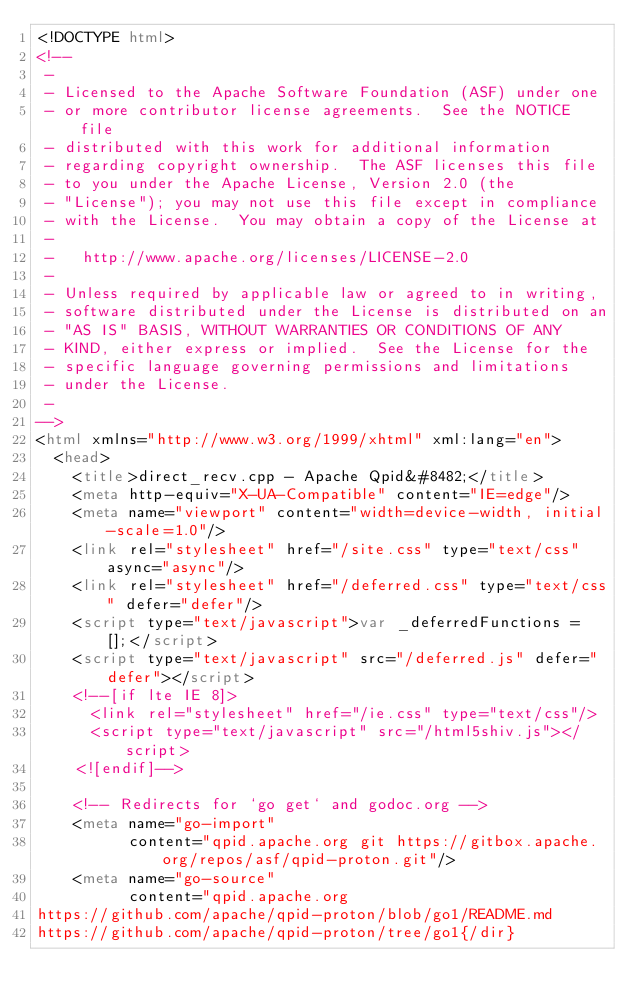Convert code to text. <code><loc_0><loc_0><loc_500><loc_500><_HTML_><!DOCTYPE html>
<!--
 -
 - Licensed to the Apache Software Foundation (ASF) under one
 - or more contributor license agreements.  See the NOTICE file
 - distributed with this work for additional information
 - regarding copyright ownership.  The ASF licenses this file
 - to you under the Apache License, Version 2.0 (the
 - "License"); you may not use this file except in compliance
 - with the License.  You may obtain a copy of the License at
 -
 -   http://www.apache.org/licenses/LICENSE-2.0
 -
 - Unless required by applicable law or agreed to in writing,
 - software distributed under the License is distributed on an
 - "AS IS" BASIS, WITHOUT WARRANTIES OR CONDITIONS OF ANY
 - KIND, either express or implied.  See the License for the
 - specific language governing permissions and limitations
 - under the License.
 -
-->
<html xmlns="http://www.w3.org/1999/xhtml" xml:lang="en">
  <head>
    <title>direct_recv.cpp - Apache Qpid&#8482;</title>
    <meta http-equiv="X-UA-Compatible" content="IE=edge"/>
    <meta name="viewport" content="width=device-width, initial-scale=1.0"/>
    <link rel="stylesheet" href="/site.css" type="text/css" async="async"/>
    <link rel="stylesheet" href="/deferred.css" type="text/css" defer="defer"/>
    <script type="text/javascript">var _deferredFunctions = [];</script>
    <script type="text/javascript" src="/deferred.js" defer="defer"></script>
    <!--[if lte IE 8]>
      <link rel="stylesheet" href="/ie.css" type="text/css"/>
      <script type="text/javascript" src="/html5shiv.js"></script>
    <![endif]-->

    <!-- Redirects for `go get` and godoc.org -->
    <meta name="go-import"
          content="qpid.apache.org git https://gitbox.apache.org/repos/asf/qpid-proton.git"/>
    <meta name="go-source"
          content="qpid.apache.org
https://github.com/apache/qpid-proton/blob/go1/README.md
https://github.com/apache/qpid-proton/tree/go1{/dir}</code> 